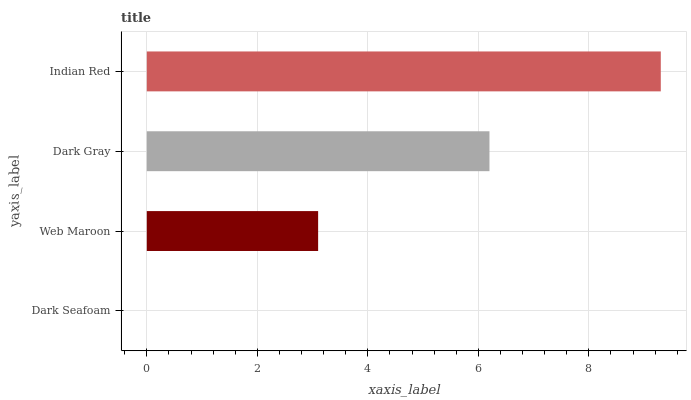Is Dark Seafoam the minimum?
Answer yes or no. Yes. Is Indian Red the maximum?
Answer yes or no. Yes. Is Web Maroon the minimum?
Answer yes or no. No. Is Web Maroon the maximum?
Answer yes or no. No. Is Web Maroon greater than Dark Seafoam?
Answer yes or no. Yes. Is Dark Seafoam less than Web Maroon?
Answer yes or no. Yes. Is Dark Seafoam greater than Web Maroon?
Answer yes or no. No. Is Web Maroon less than Dark Seafoam?
Answer yes or no. No. Is Dark Gray the high median?
Answer yes or no. Yes. Is Web Maroon the low median?
Answer yes or no. Yes. Is Web Maroon the high median?
Answer yes or no. No. Is Dark Seafoam the low median?
Answer yes or no. No. 